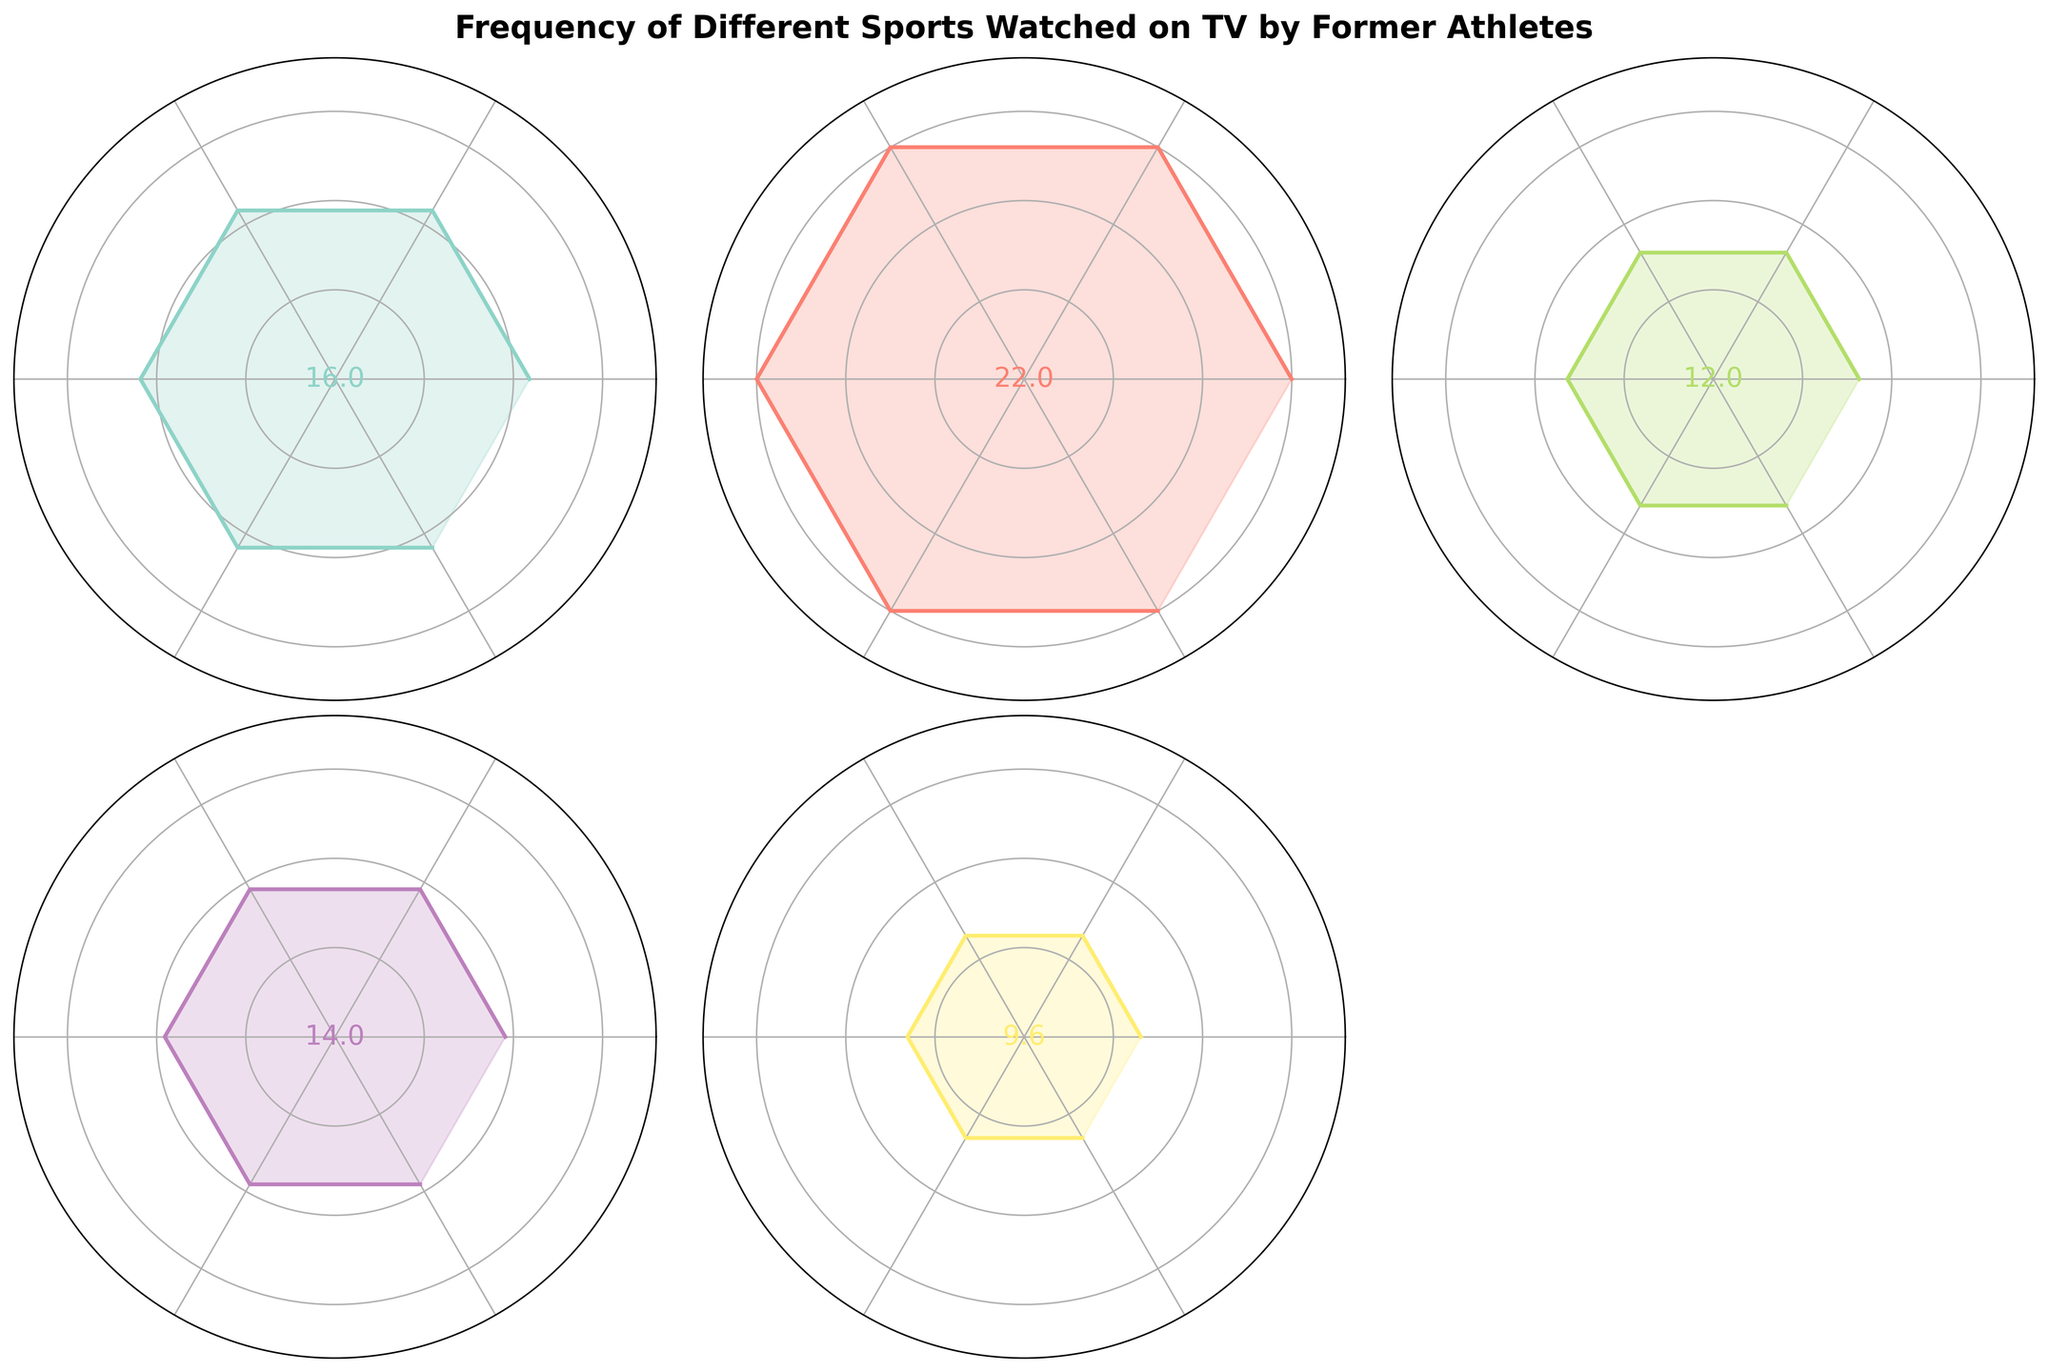What is the title of the figure? The title is prominently displayed at the top of the figure in bold and larger font compared to other text elements. It succinctly captures the main subject of the plot.
Answer: Frequency of Different Sports Watched on TV by Former Athletes Which sport has the highest mean frequency of viewership? By looking at the labeled values at the center of each subplot, the highest mean frequency is found in the subplot with the highest number.
Answer: Football Which sport has the lowest mean frequency of viewership? By looking at the labeled values at the center of each subplot, the lowest mean frequency is found in the subplot with the lowest number.
Answer: Athletics How many unique sports are displayed in the figure? Count the number of distinct subplots or the number of unique sport names in the figure.
Answer: 5 What is the mean frequency of viewership for Tennis? Locate the subplot for Tennis and read the value displayed in the center of that subplot.
Answer: 12 Compare the mean frequencies of viewership for Badminton and Ice Hockey. Which is higher? Locate the subplots for Badminton and Ice Hockey and compare the values displayed in the center of each.
Answer: Badminton Rank the sports from highest to lowest mean frequency of viewership. Read the central values from each subplot and sort them in descending order.
Answer: Football, Badminton, Ice Hockey, Tennis, Athletics What is the average of the mean frequencies of viewership for all sports? Sum all the mean frequencies and divide by the number of sports: (16+22+12+14+9)/5 = 14.6
Answer: 14.6 What is the difference in mean frequency between the sport with the highest and lowest viewership? Identify the highest mean (Football) and the lowest mean (Athletics) and calculate the difference: 22 - 9 = 13
Answer: 13 How is each sport visualized in the subplots? Each sport is visualized as a rose chart (polar plot) where the radius represents the frequency. The angle covers the complete circle, reflecting the frequency for each sport.
Answer: Rose chart 